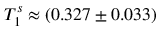Convert formula to latex. <formula><loc_0><loc_0><loc_500><loc_500>T _ { 1 } ^ { s } \approx ( 0 . 3 2 7 \pm 0 . 0 3 3 )</formula> 